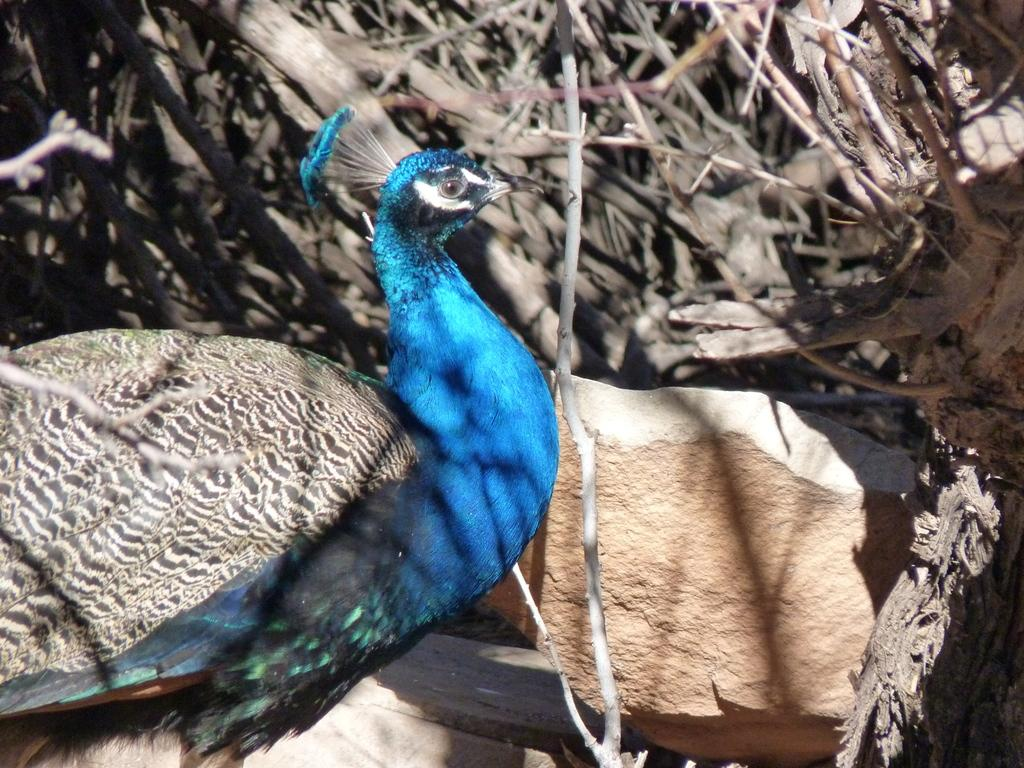What animal is the main subject of the image? There is a peacock in the image. What is the peacock standing in front of? The peacock is in front of a rock. What can be seen in the background of the image? There are plants and wooden trunks in the background of the image. What type of destruction is the farmer causing to the quince trees in the image? There is no farmer or quince trees present in the image; it features a peacock in front of a rock with plants and wooden trunks in the background. 